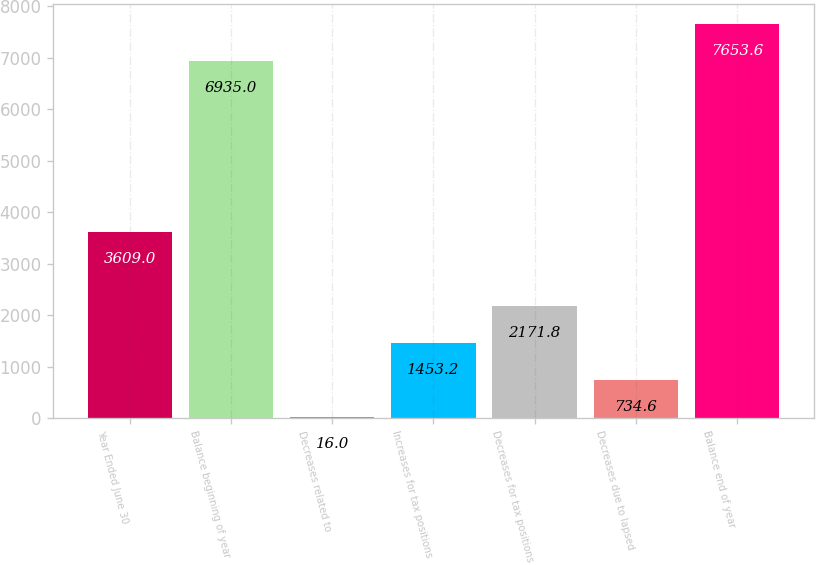Convert chart to OTSL. <chart><loc_0><loc_0><loc_500><loc_500><bar_chart><fcel>Year Ended June 30<fcel>Balance beginning of year<fcel>Decreases related to<fcel>Increases for tax positions<fcel>Decreases for tax positions<fcel>Decreases due to lapsed<fcel>Balance end of year<nl><fcel>3609<fcel>6935<fcel>16<fcel>1453.2<fcel>2171.8<fcel>734.6<fcel>7653.6<nl></chart> 